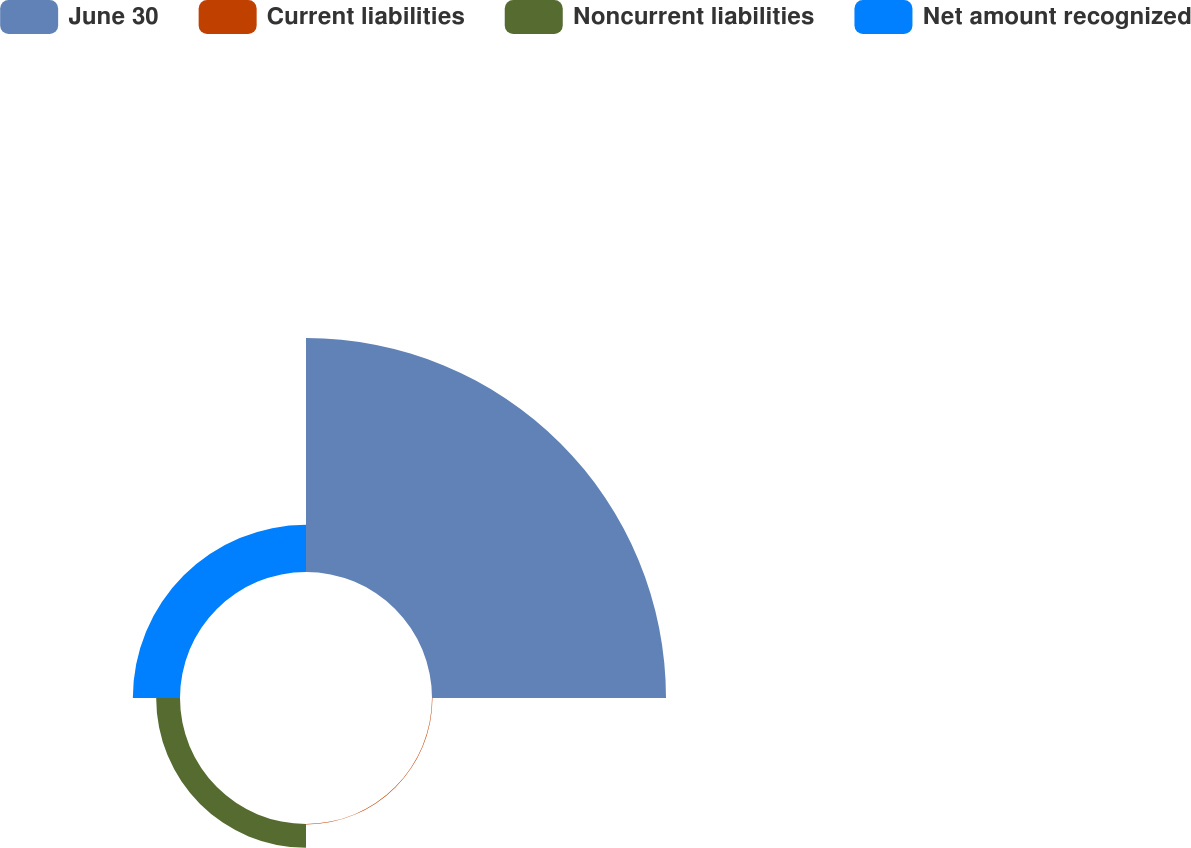Convert chart to OTSL. <chart><loc_0><loc_0><loc_500><loc_500><pie_chart><fcel>June 30<fcel>Current liabilities<fcel>Noncurrent liabilities<fcel>Net amount recognized<nl><fcel>76.61%<fcel>0.15%<fcel>7.8%<fcel>15.44%<nl></chart> 